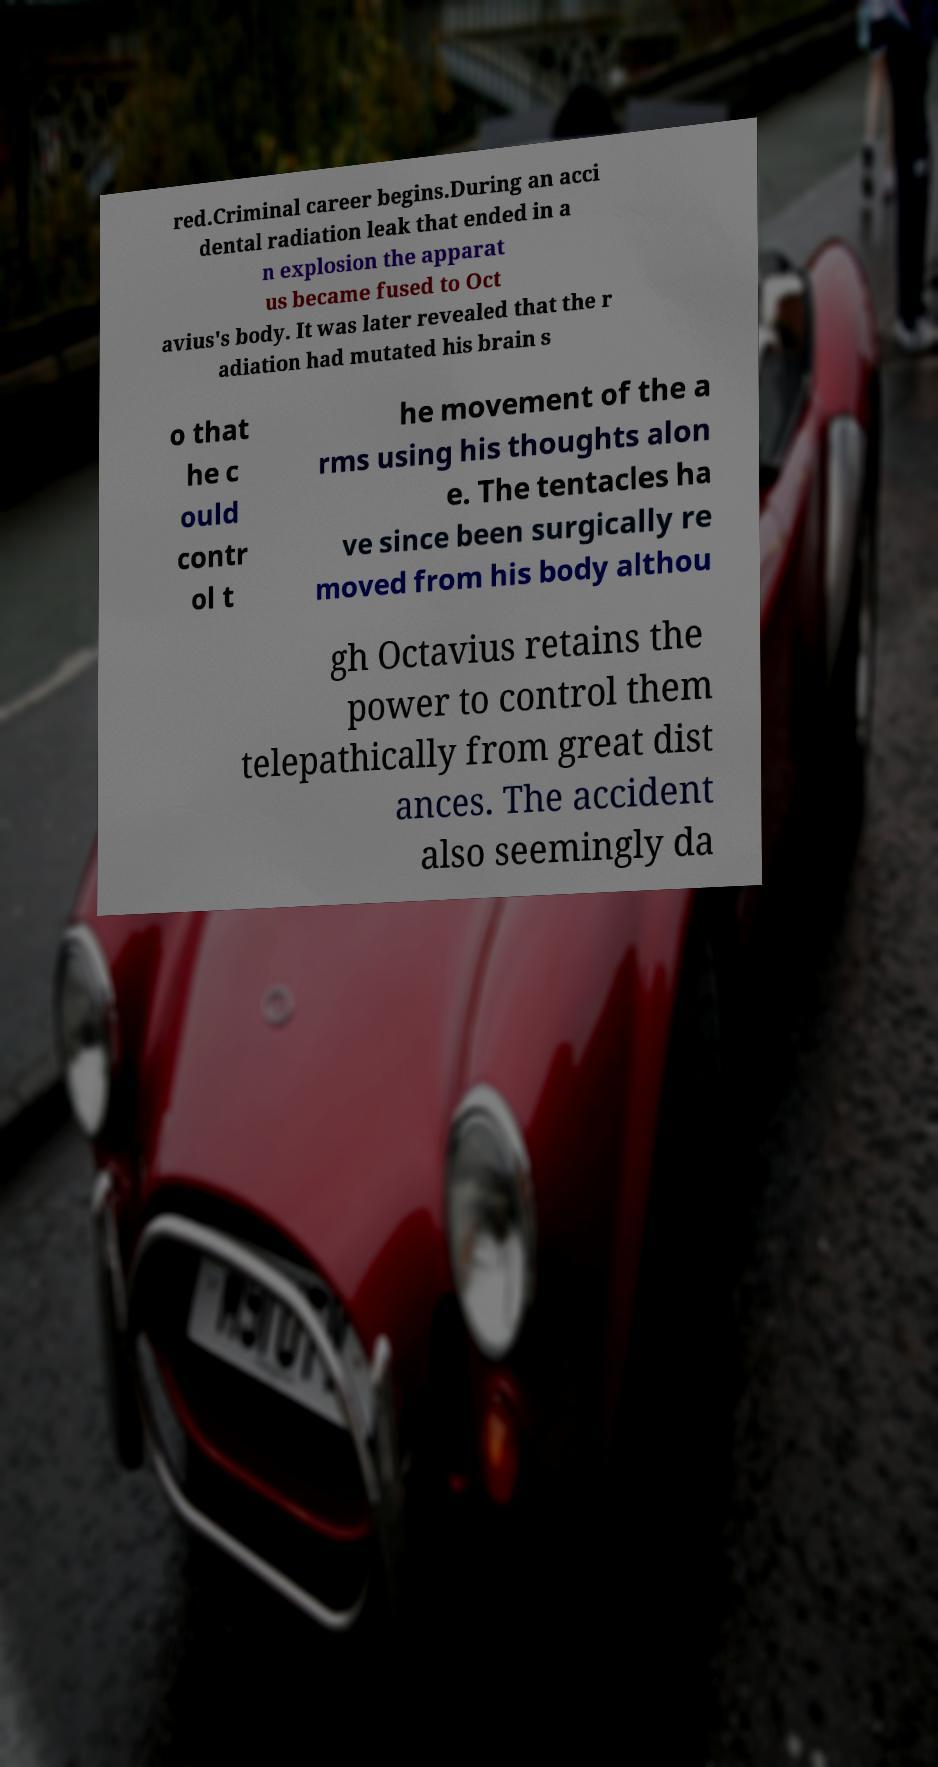I need the written content from this picture converted into text. Can you do that? red.Criminal career begins.During an acci dental radiation leak that ended in a n explosion the apparat us became fused to Oct avius's body. It was later revealed that the r adiation had mutated his brain s o that he c ould contr ol t he movement of the a rms using his thoughts alon e. The tentacles ha ve since been surgically re moved from his body althou gh Octavius retains the power to control them telepathically from great dist ances. The accident also seemingly da 